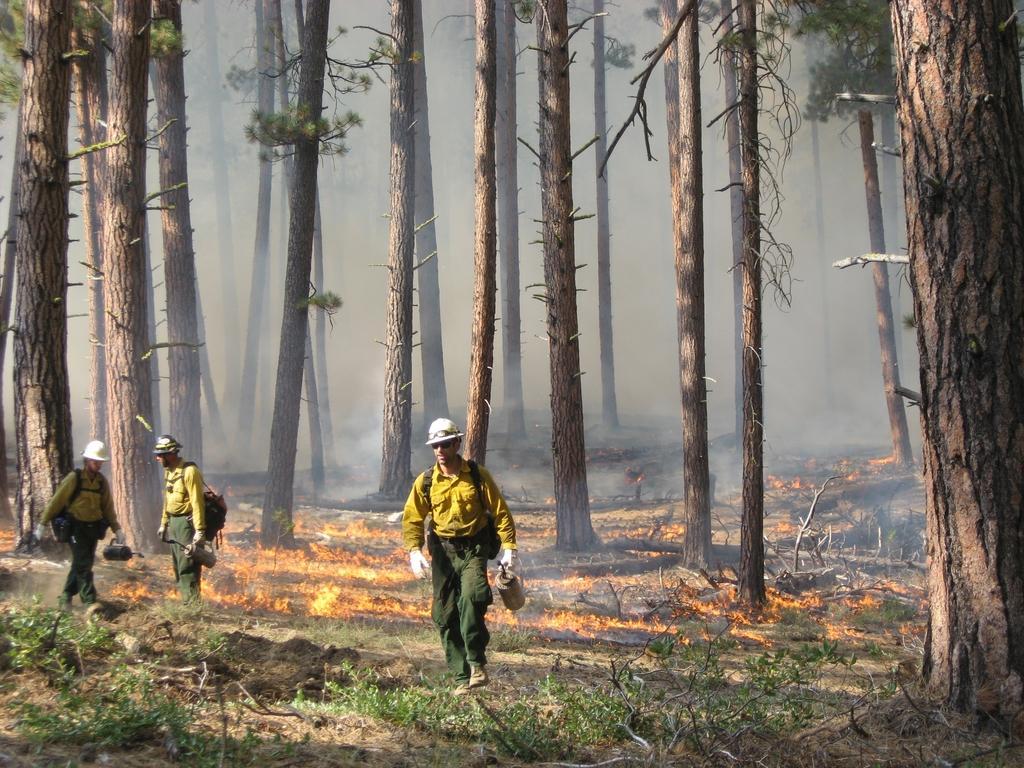Describe this image in one or two sentences. In this image there is a man standing and holding an object, there are two men walking and holding an object, they are wearing bags, they are wearing helmets, there are tree trunks, there is fire, there are plants towards the bottom of the image. 